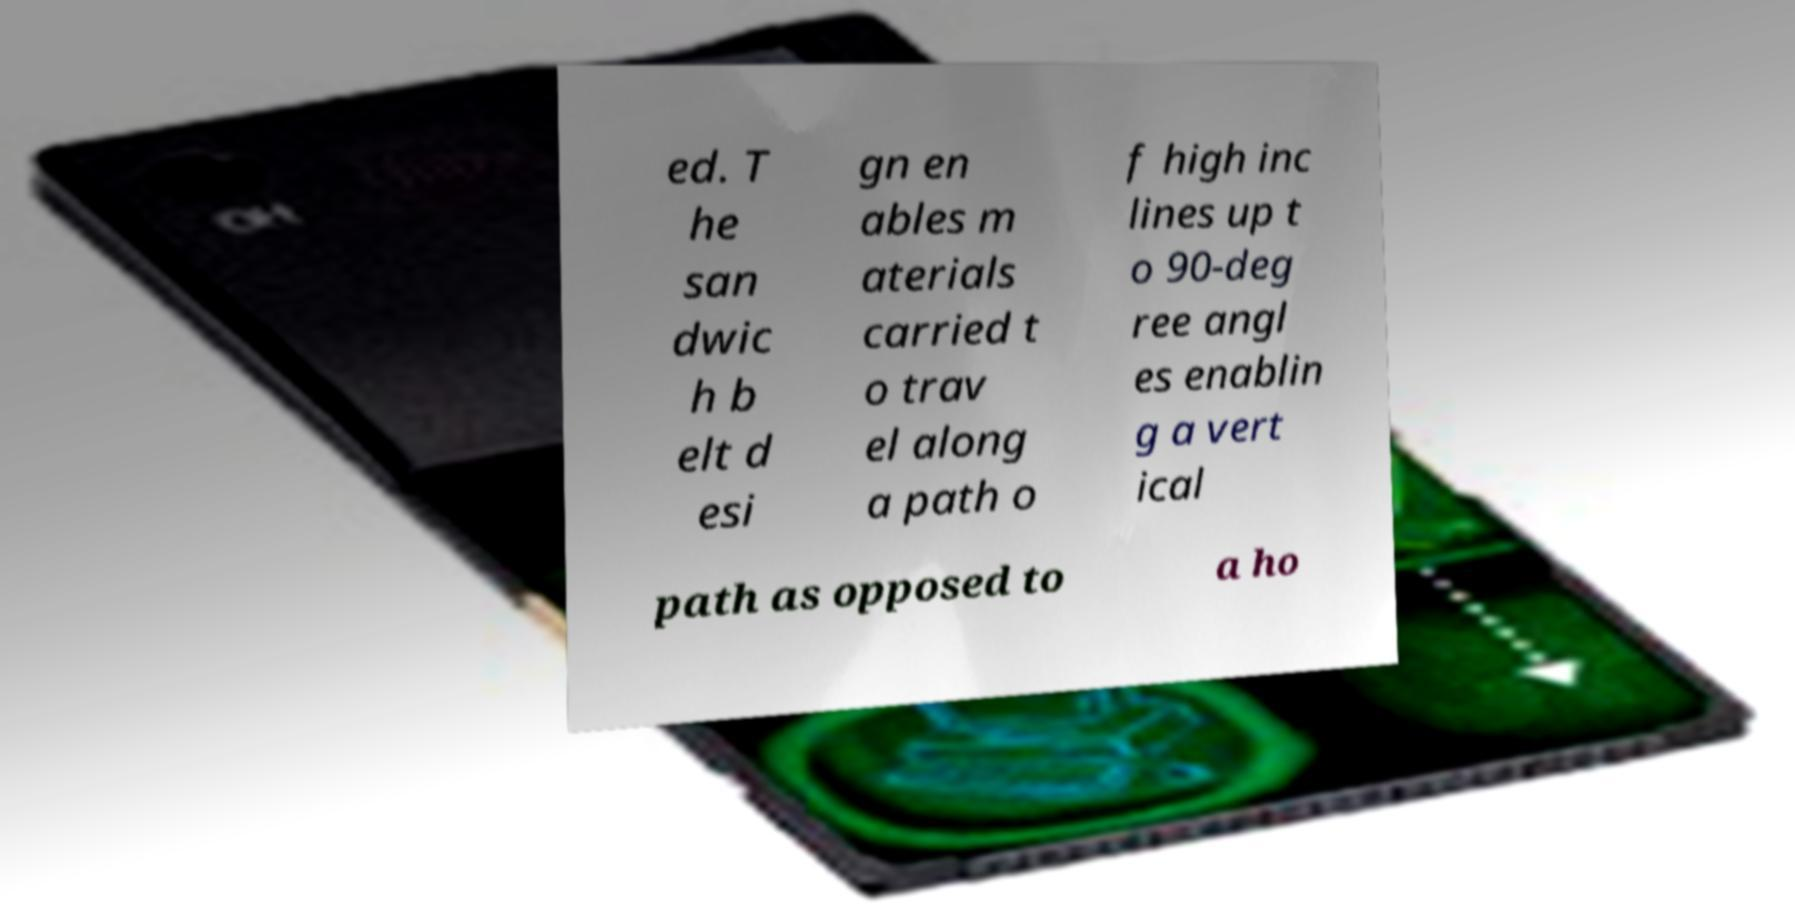Could you extract and type out the text from this image? ed. T he san dwic h b elt d esi gn en ables m aterials carried t o trav el along a path o f high inc lines up t o 90-deg ree angl es enablin g a vert ical path as opposed to a ho 